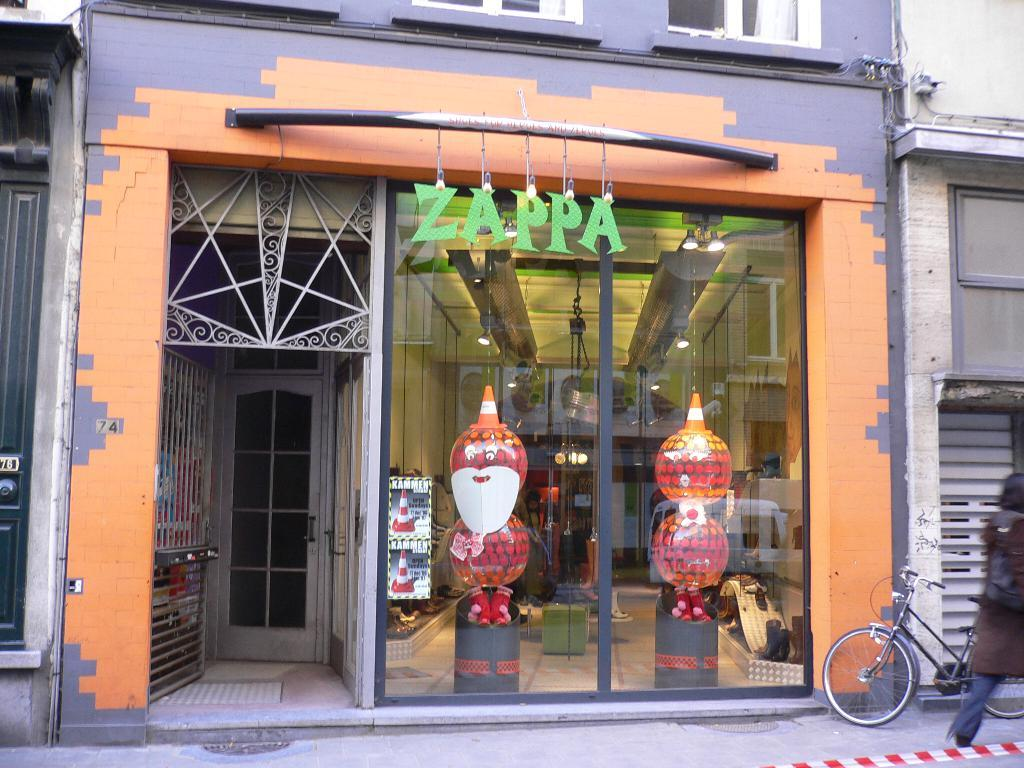Who or what is present in the image? There is a person in the image. What mode of transportation can be seen in the image? There is a bicycle in the image. What type of architectural feature is visible in the image? There is a framed glass wall in the image. Is there a way to enter or exit the space in the image? Yes, there is a door in the image. What type of lighting is present in the image? There are lights on the ceiling in the image. Are there any other objects or features present in the image? Yes, there are other objects present in the image. What type of gold whip is being used to generate profit in the image? There is no gold whip or any mention of profit in the image; it features a person, a bicycle, a framed glass wall, a door, ceiling lights, and other objects. 